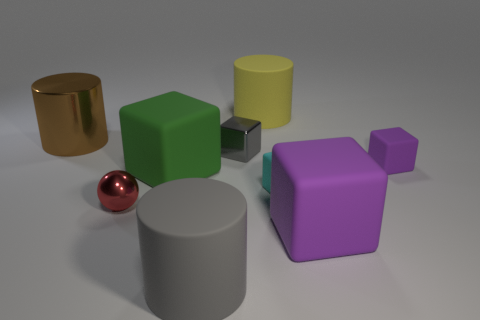Subtract all big rubber cylinders. How many cylinders are left? 1 Subtract all brown cylinders. How many cylinders are left? 2 Subtract all cylinders. How many objects are left? 6 Subtract 3 cylinders. How many cylinders are left? 0 Subtract all gray cubes. Subtract all cyan spheres. How many cubes are left? 4 Subtract all brown blocks. How many yellow cylinders are left? 1 Subtract all small cyan matte cubes. Subtract all cyan objects. How many objects are left? 7 Add 2 large green rubber cubes. How many large green rubber cubes are left? 3 Add 8 small gray cubes. How many small gray cubes exist? 9 Subtract 1 brown cylinders. How many objects are left? 8 